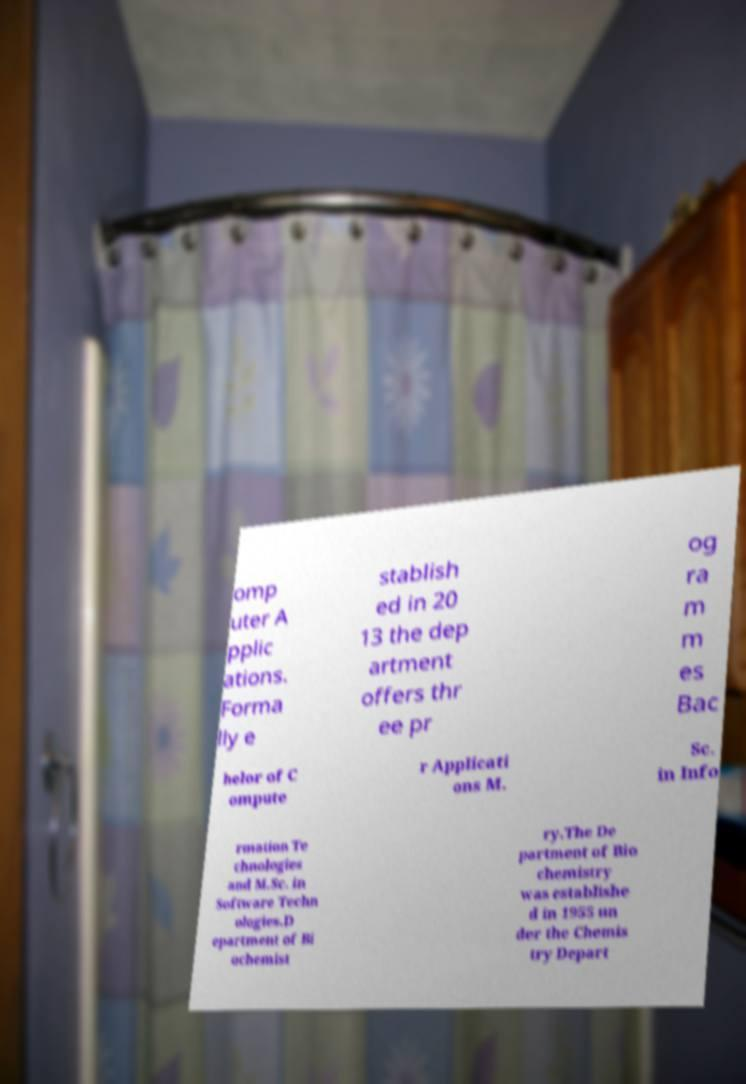For documentation purposes, I need the text within this image transcribed. Could you provide that? omp uter A pplic ations. Forma lly e stablish ed in 20 13 the dep artment offers thr ee pr og ra m m es Bac helor of C ompute r Applicati ons M. Sc. in Info rmation Te chnologies and M.Sc. in Software Techn ologies.D epartment of Bi ochemist ry.The De partment of Bio chemistry was establishe d in 1955 un der the Chemis try Depart 